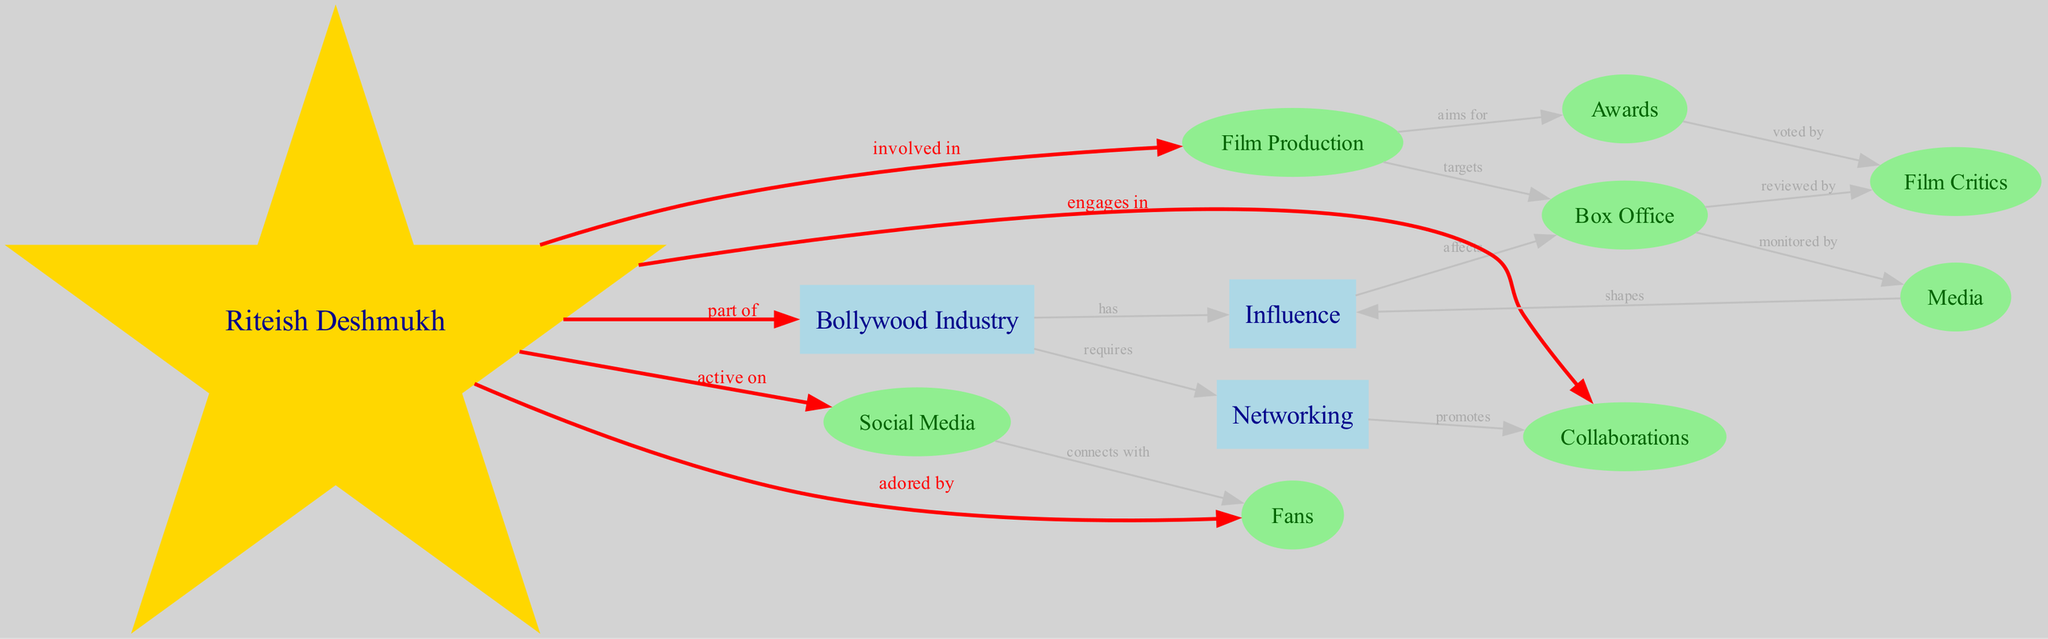What is the main focus of the concept map? The concept map centers around the "Bollywood Industry," which serves as the primary node that connects various elements such as influence and networking.
Answer: Bollywood Industry How many nodes are present in the diagram? By counting all unique nodes in the diagram, including Bollywood Industry, Influence, Networking, and others, we arrive at a total of 12 nodes.
Answer: 12 Which node does Riteish Deshmukh engage with through collaborations? The diagram indicates that Riteish Deshmukh has an edge connecting to the "Collaborations" node, signifying his active participation in collaborative ventures.
Answer: Collaborations What does the "Social Media" node connect to in relation to fans? The "Social Media" node has a direct connection to the "Fans" node, demonstrating how it serves as a platform for interaction between them.
Answer: Fans How does the "Influence" node affect the "Box Office"? The diagram shows a directional edge from "Influence" to "Box Office," indicating that influence has a significant impact on the box office performance of films.
Answer: Affects What is the relationship between "Film Production" and "Awards"? The diagram indicates that "Film Production" aims for "Awards," illustrating the goal of film productions in seeking recognition through awards.
Answer: Aims for In what way is the "Box Office" monitored? The "Box Office" has a connection to the "Media" node, which indicates that the performance and earnings of films are closely monitored and reported by the media.
Answer: Monitored by Who are the individuals that vote for the "Awards"? The diagram specifies that "Film Critics" are the ones who vote for "Awards," highlighting the role of critics in determining award recipients.
Answer: Film Critics What effect does the "Media" have on "Influence"? The "Media" node connects to the "Influence" node, suggesting that media has a role in shaping the influence within the Bollywood industry.
Answer: Shapes 